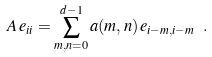Convert formula to latex. <formula><loc_0><loc_0><loc_500><loc_500>A \, e _ { i i } = \sum _ { m , n = 0 } ^ { d - 1 } a ( m , n ) \, e _ { i - m , i - m } \ .</formula> 